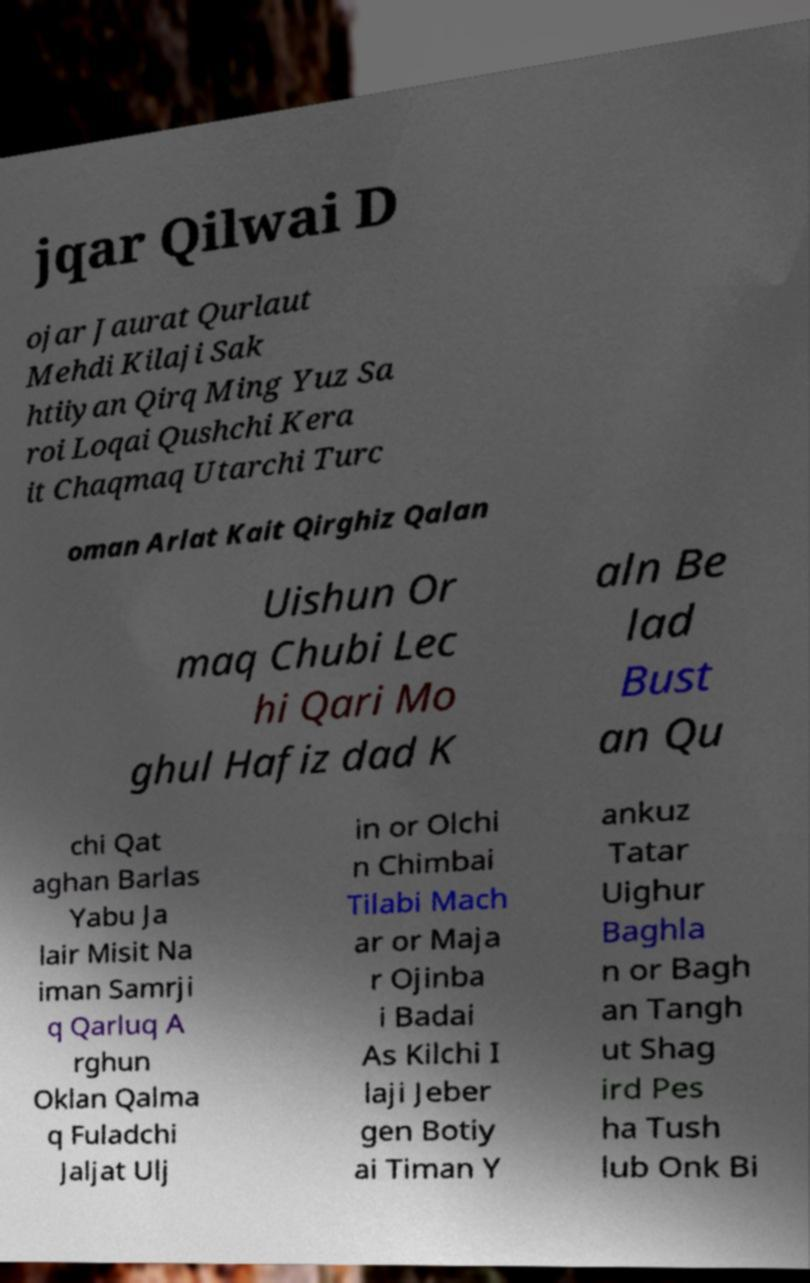I need the written content from this picture converted into text. Can you do that? jqar Qilwai D ojar Jaurat Qurlaut Mehdi Kilaji Sak htiiyan Qirq Ming Yuz Sa roi Loqai Qushchi Kera it Chaqmaq Utarchi Turc oman Arlat Kait Qirghiz Qalan Uishun Or maq Chubi Lec hi Qari Mo ghul Hafiz dad K aln Be lad Bust an Qu chi Qat aghan Barlas Yabu Ja lair Misit Na iman Samrji q Qarluq A rghun Oklan Qalma q Fuladchi Jaljat Ulj in or Olchi n Chimbai Tilabi Mach ar or Maja r Ojinba i Badai As Kilchi I laji Jeber gen Botiy ai Timan Y ankuz Tatar Uighur Baghla n or Bagh an Tangh ut Shag ird Pes ha Tush lub Onk Bi 